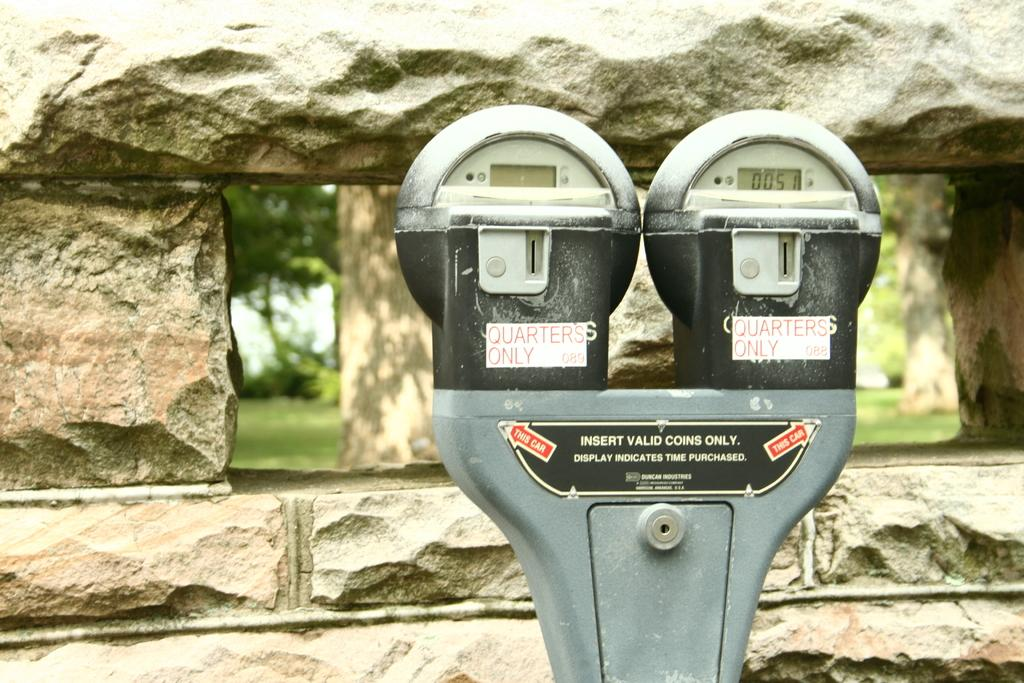<image>
Write a terse but informative summary of the picture. Two parking meters side by side with a sign on them that reads quarters only. 